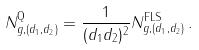Convert formula to latex. <formula><loc_0><loc_0><loc_500><loc_500>N ^ { \text {Q} } _ { g , ( d _ { 1 } , d _ { 2 } ) } = \frac { 1 } { ( d _ { 1 } d _ { 2 } ) ^ { 2 } } N ^ { \text {FLS} } _ { g , ( d _ { 1 } , d _ { 2 } ) } \, .</formula> 